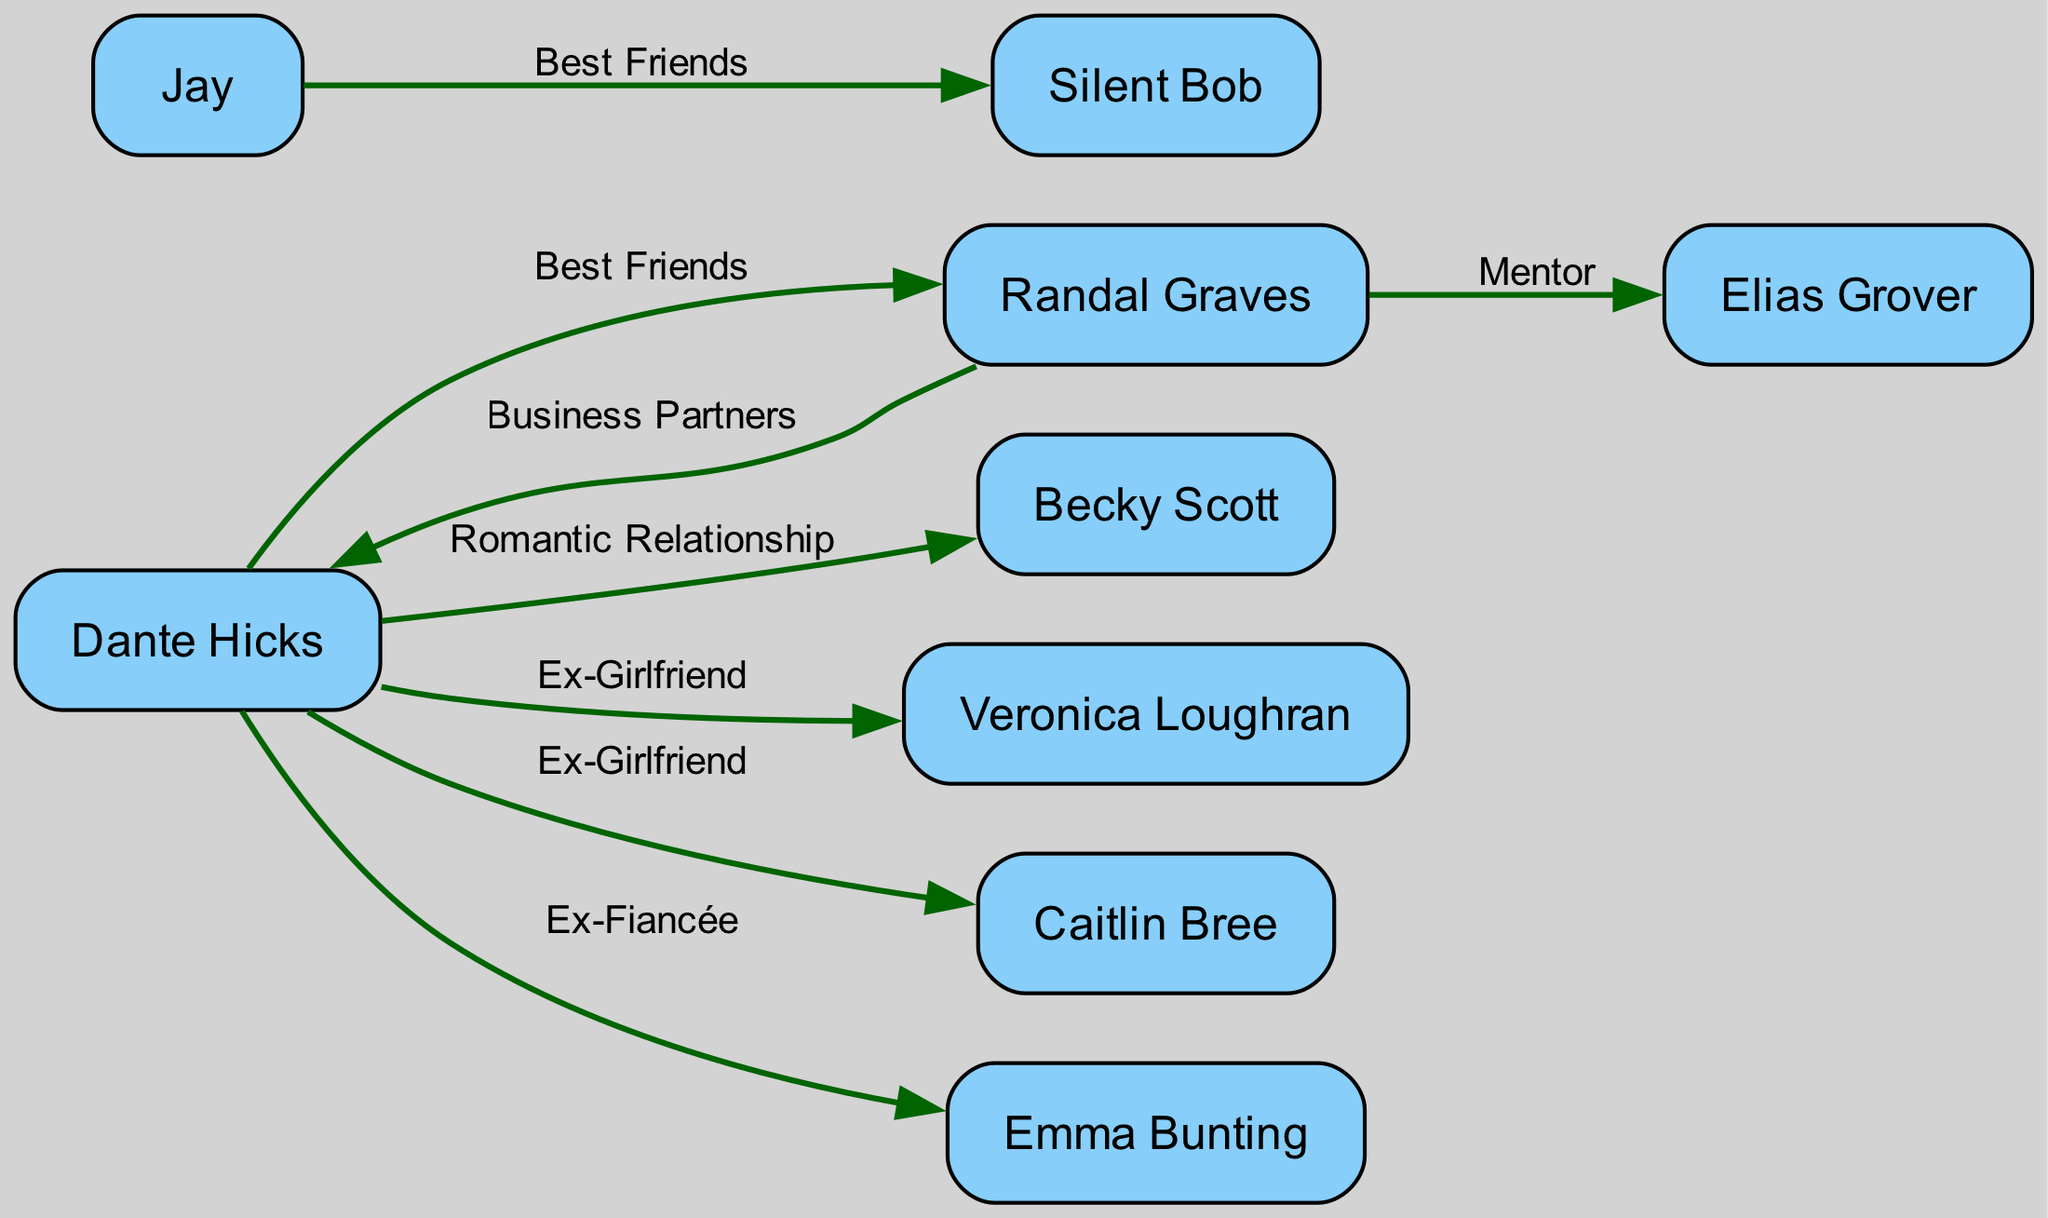What is the total number of characters represented in the diagram? The diagram includes a set of nodes that represent characters. To find the total number of characters, we count the nodes listed in the data, which show a total of 9 distinct characters: Dante Hicks, Randal Graves, Becky Scott, Elias Grover, Jay, Silent Bob, Veronica Loughran, Caitlin Bree, and Emma Bunting.
Answer: 9 Who is Dante Hicks' romantic partner in the diagram? The relationship labeled as "Romantic Relationship" is specifically linked to the edge connecting Dante Hicks to Becky Scott. Therefore, after examining the edge labels, it is clear that Becky Scott is represented as Dante Hicks' romantic partner.
Answer: Becky Scott What type of relationship exists between Dante Hicks and Veronica Loughran? To determine the relationship type, we look at the connection between Dante Hicks and Veronica Loughran in the diagram. The edge connecting them is labeled "Ex-Girlfriend", indicating the nature of their relationship.
Answer: Ex-Girlfriend Which character has the role of mentor to Randal Graves? In the diagram, the edge from Randal Graves to Elias Grover is labeled "Mentor." This indicates that Elias Grover has the role of mentor to Randal Graves, based on the information provided in the relationships.
Answer: Elias Grover How many characters does Dante Hicks have ex-relationships with? By counting the edges connected to Dante Hicks that are labeled with relationship types indicating past romantic connections, we find three ex-relationships: with Veronica Loughran, Caitlin Bree, and Emma Bunting. Thus, the total is three characters.
Answer: 3 What is the nature of the relationship between Jay and Silent Bob? The relationship is indicated by the edge connecting Jay and Silent Bob, which is labeled as "Best Friends." This label describes the positive friendship connecting the two characters in the diagram.
Answer: Best Friends How many total relationships are depicted in the diagram? To find the total number of relationships, we can count the edges connecting the nodes. The data shows a total of 8 edges, each depicting a specific relationship between the characters. Thus, the total number of relationships is 8.
Answer: 8 Which character is best friends with Randal Graves? The diagram does not show a direct line indicating a best friend relationship for Randal Graves with any specific character other than his connection to Dante Hicks, which is labeled as "Best Friends." Hence, Dante Hicks is identified as his best friend.
Answer: Dante Hicks What is the relationship label between Randal Graves and Dante Hicks? The edge connecting Randal Graves and Dante Hicks displays two labels: "Best Friends" and "Business Partners." This indicates Randal Graves has dual relationships with Dante Hicks, being both a best friend and a business partner.
Answer: Best Friends, Business Partners 